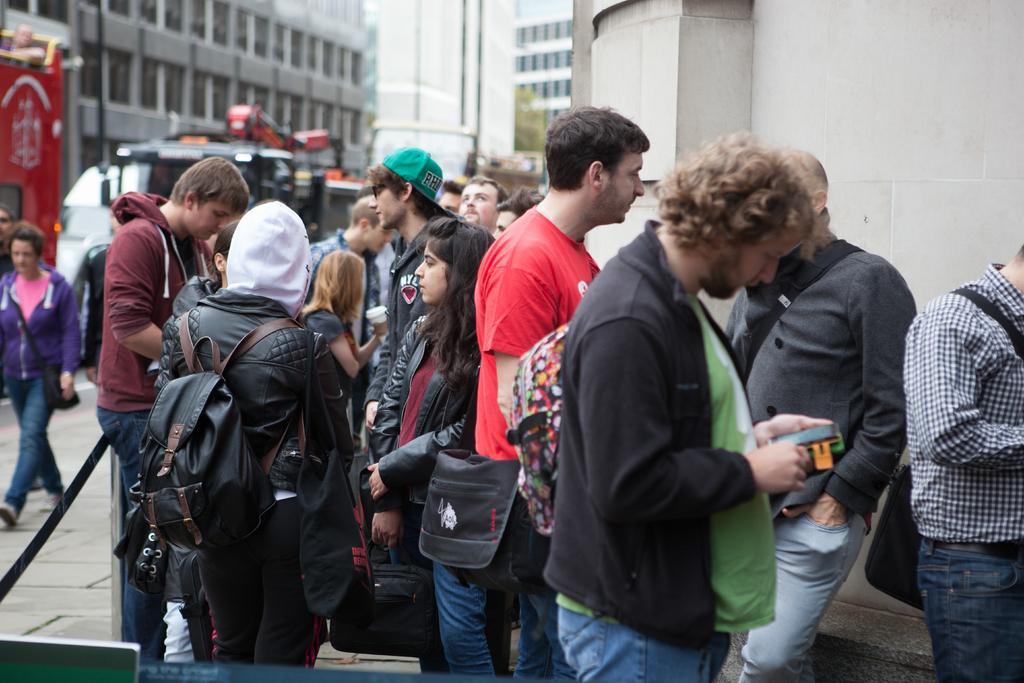In one or two sentences, can you explain what this image depicts? In this image we can see a group of people standing and few people are holding some objects. There are few objects at the bottom of the image. There are few buildings in the image. There are few vehicles in the image. There is a tree in the image. 